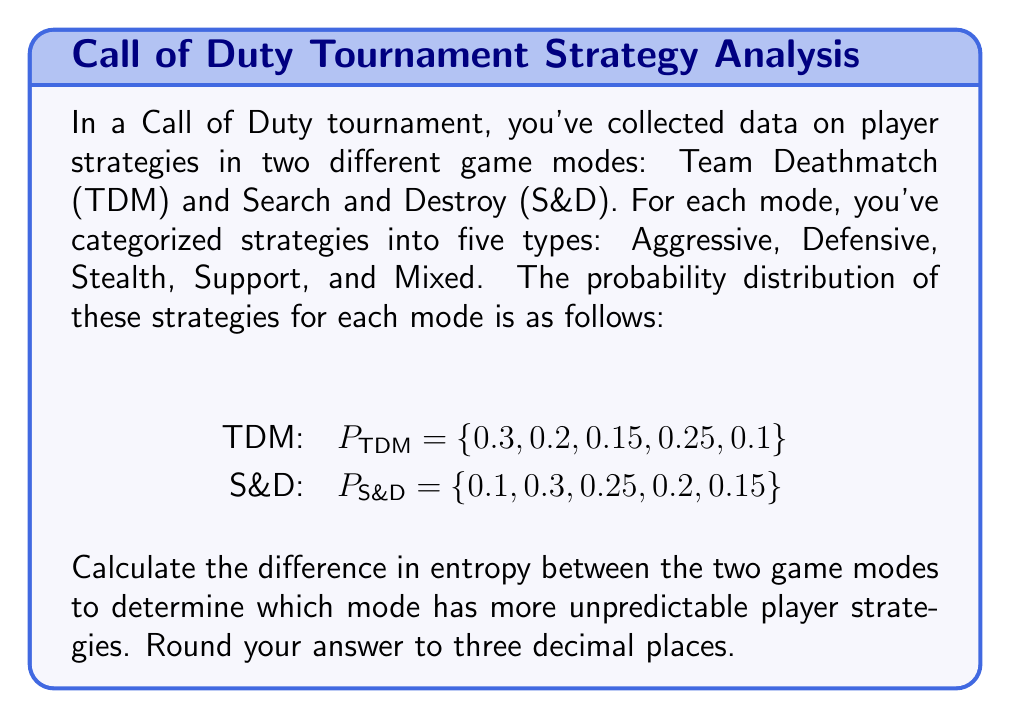Solve this math problem. To solve this problem, we need to calculate the entropy for each game mode and then find the difference. Let's break it down step-by-step:

1. The formula for entropy is:
   $$S = -k\sum_{i=1}^{n} p_i \ln(p_i)$$
   where $k$ is Boltzmann's constant (which we'll assume is 1 for simplicity), and $p_i$ is the probability of each strategy.

2. Calculate entropy for Team Deathmatch (TDM):
   $$\begin{align}
   S_{\text{TDM}} &= -[(0.3 \ln(0.3) + 0.2 \ln(0.2) + 0.15 \ln(0.15) + 0.25 \ln(0.25) + 0.1 \ln(0.1)] \\
   &= -[-0.3611 - 0.3219 - 0.2849 - 0.3466 - 0.2303] \\
   &= 1.5448
   \end{align}$$

3. Calculate entropy for Search and Destroy (S&D):
   $$\begin{align}
   S_{\text{S&D}} &= -[(0.1 \ln(0.1) + 0.3 \ln(0.3) + 0.25 \ln(0.25) + 0.2 \ln(0.2) + 0.15 \ln(0.15)] \\
   &= -[-0.2303 - 0.3611 - 0.3466 - 0.3219 - 0.2849] \\
   &= 1.5448
   \end{align}$$

4. Calculate the difference in entropy:
   $$\begin{align}
   \Delta S &= S_{\text{S&D}} - S_{\text{TDM}} \\
   &= 1.5448 - 1.5448 \\
   &= 0
   \end{align}$$

5. Round the result to three decimal places:
   $\Delta S = 0.000$
Answer: 0.000 